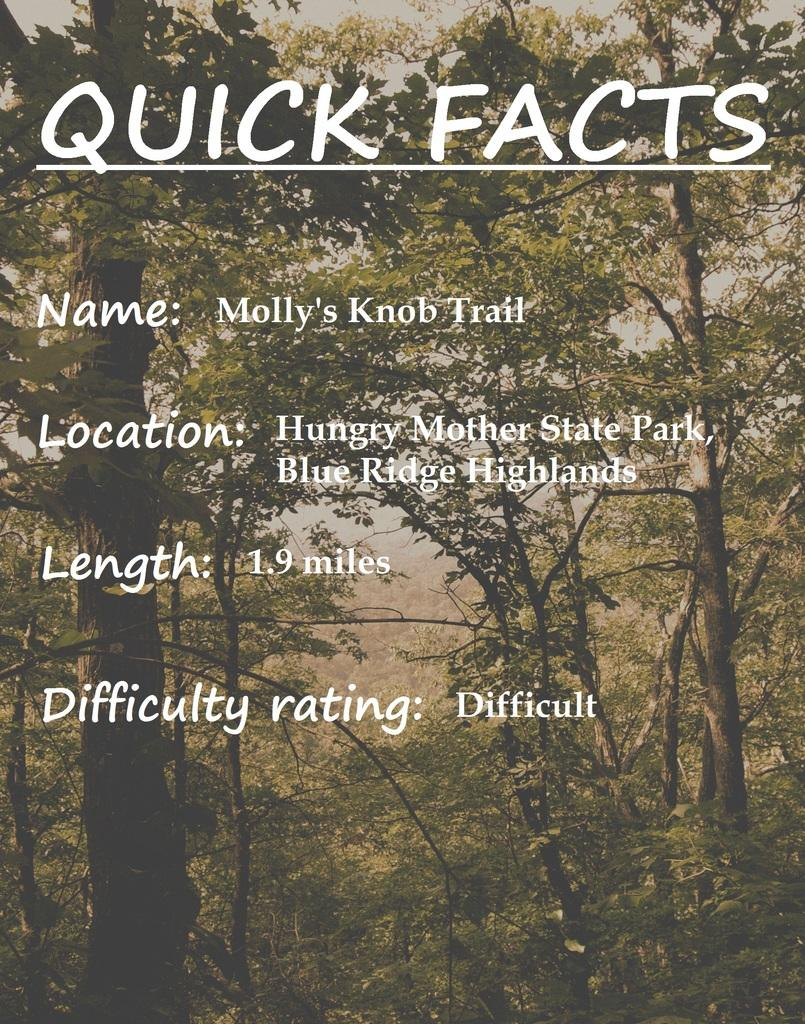<image>
Give a short and clear explanation of the subsequent image. An informational poster offers quick facts about a Blue Ridge Highlands hiking spot called Molly's Knob Trail. 